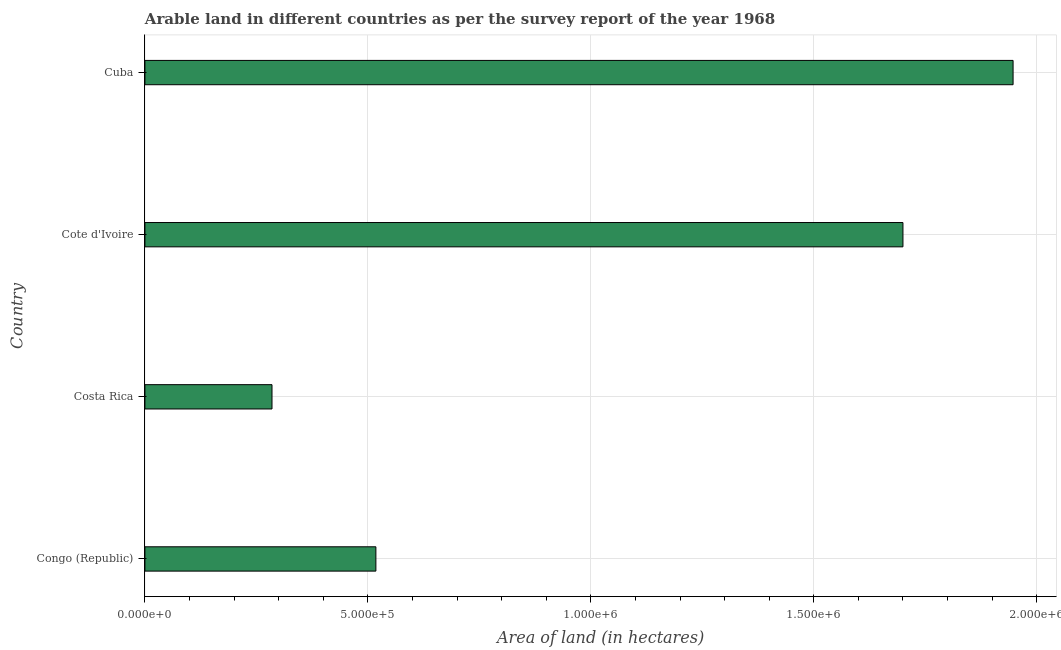What is the title of the graph?
Offer a very short reply. Arable land in different countries as per the survey report of the year 1968. What is the label or title of the X-axis?
Your answer should be compact. Area of land (in hectares). What is the area of land in Costa Rica?
Keep it short and to the point. 2.85e+05. Across all countries, what is the maximum area of land?
Keep it short and to the point. 1.95e+06. Across all countries, what is the minimum area of land?
Make the answer very short. 2.85e+05. In which country was the area of land maximum?
Give a very brief answer. Cuba. What is the sum of the area of land?
Ensure brevity in your answer.  4.45e+06. What is the difference between the area of land in Cote d'Ivoire and Cuba?
Offer a very short reply. -2.47e+05. What is the average area of land per country?
Keep it short and to the point. 1.11e+06. What is the median area of land?
Your answer should be compact. 1.11e+06. In how many countries, is the area of land greater than 1500000 hectares?
Make the answer very short. 2. What is the ratio of the area of land in Cote d'Ivoire to that in Cuba?
Ensure brevity in your answer.  0.87. Is the area of land in Congo (Republic) less than that in Cuba?
Your answer should be compact. Yes. Is the difference between the area of land in Congo (Republic) and Cuba greater than the difference between any two countries?
Provide a short and direct response. No. What is the difference between the highest and the second highest area of land?
Your response must be concise. 2.47e+05. Is the sum of the area of land in Congo (Republic) and Cote d'Ivoire greater than the maximum area of land across all countries?
Make the answer very short. Yes. What is the difference between the highest and the lowest area of land?
Make the answer very short. 1.66e+06. Are all the bars in the graph horizontal?
Your answer should be very brief. Yes. How many countries are there in the graph?
Your response must be concise. 4. What is the difference between two consecutive major ticks on the X-axis?
Offer a very short reply. 5.00e+05. Are the values on the major ticks of X-axis written in scientific E-notation?
Offer a very short reply. Yes. What is the Area of land (in hectares) in Congo (Republic)?
Keep it short and to the point. 5.18e+05. What is the Area of land (in hectares) of Costa Rica?
Offer a very short reply. 2.85e+05. What is the Area of land (in hectares) in Cote d'Ivoire?
Your answer should be very brief. 1.70e+06. What is the Area of land (in hectares) of Cuba?
Offer a terse response. 1.95e+06. What is the difference between the Area of land (in hectares) in Congo (Republic) and Costa Rica?
Give a very brief answer. 2.33e+05. What is the difference between the Area of land (in hectares) in Congo (Republic) and Cote d'Ivoire?
Give a very brief answer. -1.18e+06. What is the difference between the Area of land (in hectares) in Congo (Republic) and Cuba?
Offer a terse response. -1.43e+06. What is the difference between the Area of land (in hectares) in Costa Rica and Cote d'Ivoire?
Your response must be concise. -1.42e+06. What is the difference between the Area of land (in hectares) in Costa Rica and Cuba?
Make the answer very short. -1.66e+06. What is the difference between the Area of land (in hectares) in Cote d'Ivoire and Cuba?
Provide a succinct answer. -2.47e+05. What is the ratio of the Area of land (in hectares) in Congo (Republic) to that in Costa Rica?
Keep it short and to the point. 1.82. What is the ratio of the Area of land (in hectares) in Congo (Republic) to that in Cote d'Ivoire?
Offer a very short reply. 0.3. What is the ratio of the Area of land (in hectares) in Congo (Republic) to that in Cuba?
Provide a short and direct response. 0.27. What is the ratio of the Area of land (in hectares) in Costa Rica to that in Cote d'Ivoire?
Your answer should be very brief. 0.17. What is the ratio of the Area of land (in hectares) in Costa Rica to that in Cuba?
Keep it short and to the point. 0.15. What is the ratio of the Area of land (in hectares) in Cote d'Ivoire to that in Cuba?
Provide a short and direct response. 0.87. 